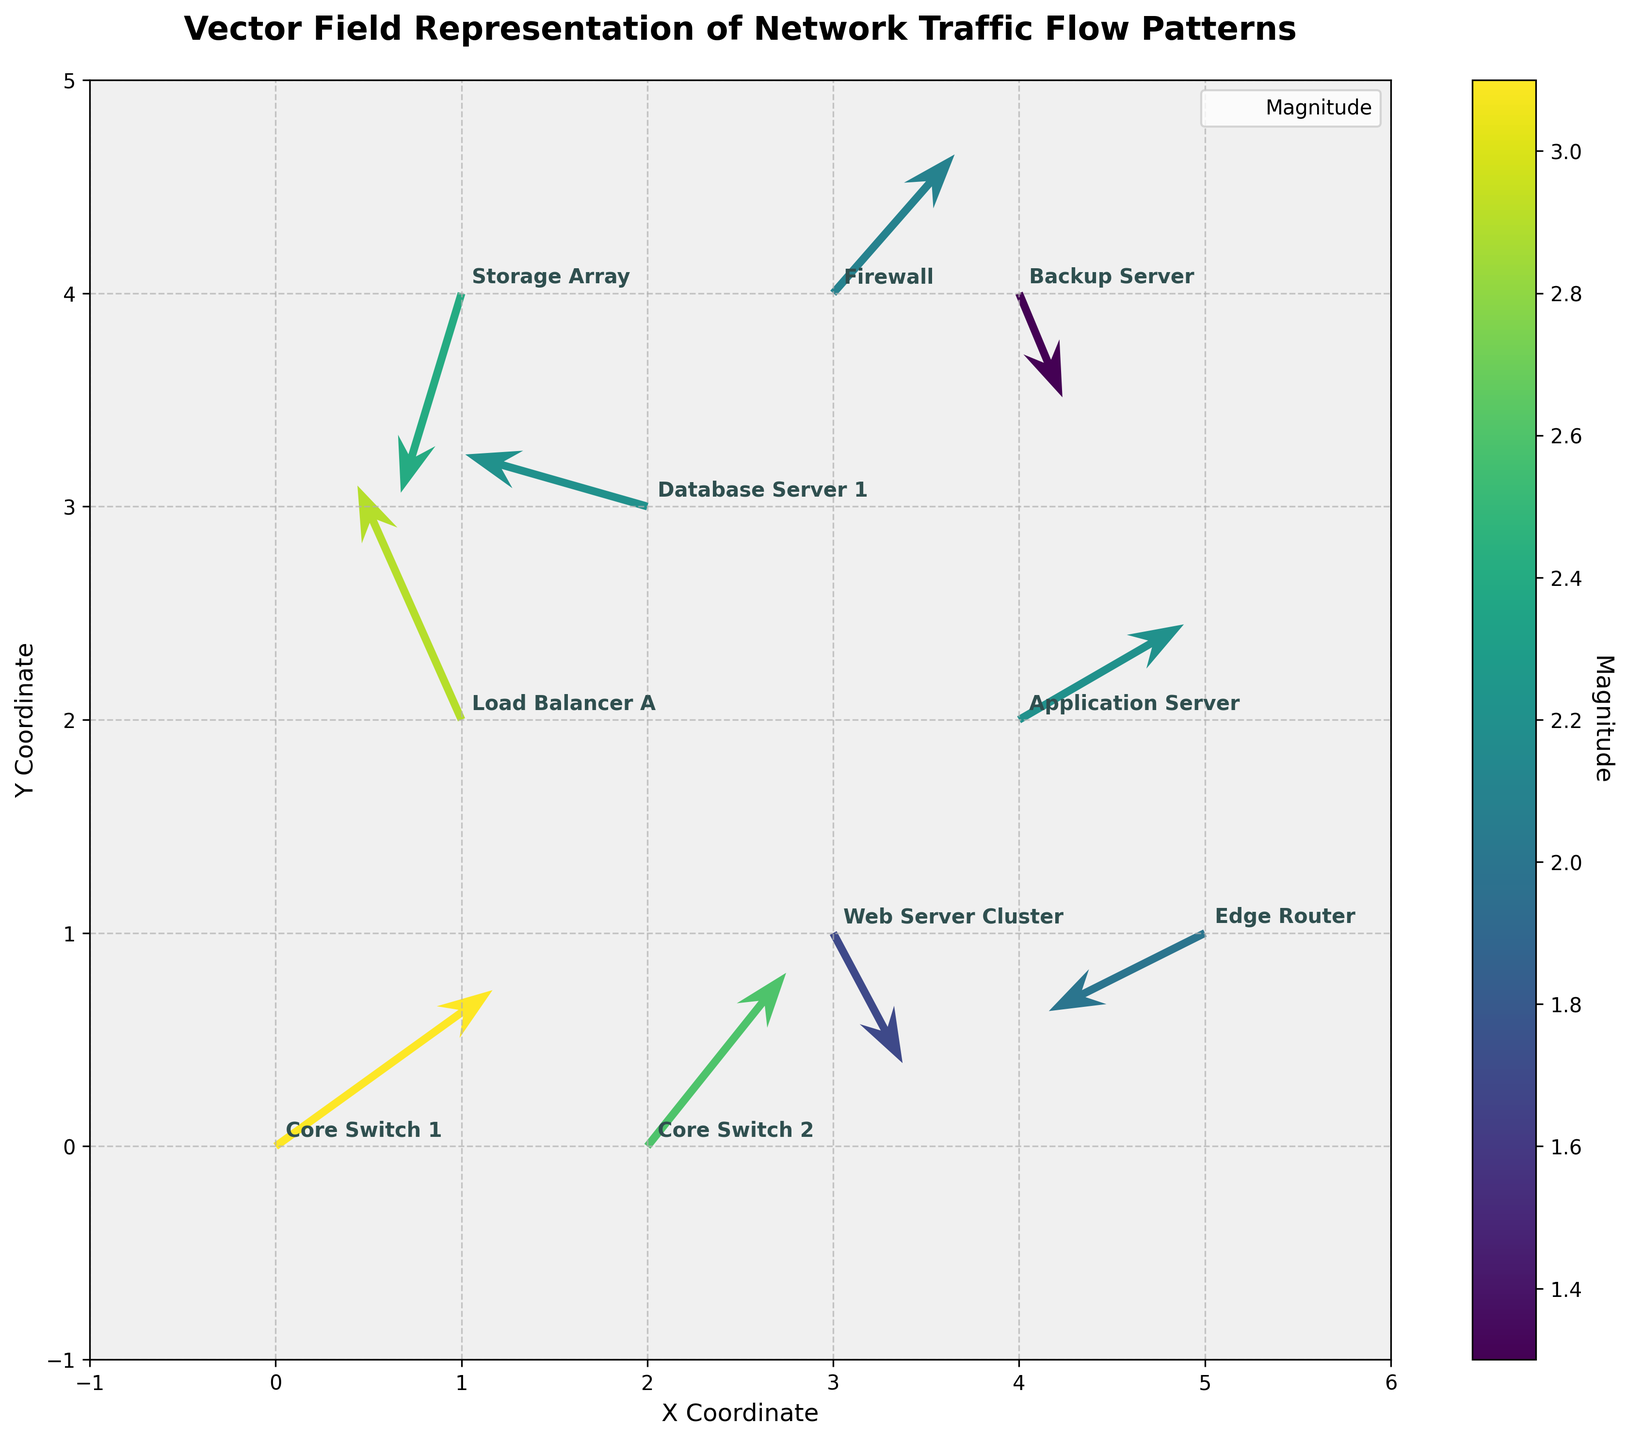Which data point has the highest magnitude? The colorbar indicates the magnitude of each vector. By observing the colors, the data point at (0,0) labeled "Core Switch 1" has the highest intensity, meaning it has the highest magnitude.
Answer: Core Switch 1 What is the title of the plot? The title is typically positioned at the top of the plot. In this plot, the title reads "Vector Field Representation of Network Traffic Flow Patterns".
Answer: Vector Field Representation of Network Traffic Flow Patterns What is the direction of the vector at (4, 2)? The vector at (4, 2) is labeled "Application Server". Observing its arrow, it points upward and to the right. Thus, its direction is northeast.
Answer: Northeast Which data point has a vector pointing southeast? By examining the plot, the vector at (1, 4) labeled "Storage Array" points downward and to the right, which corresponds to a southeast direction.
Answer: Storage Array Compare the magnitudes of the vectors at (1, 2) and (4, 4). Which one is larger? The color of the vector at (1, 2) is more intense than that of the vector at (4, 4), indicating a higher magnitude.
Answer: The vector at (1, 2) Add the U components of the vectors at (3, 1) and (2, 3). What is the result? The U component at (3, 1) is 0.8 and at (2, 3) is -2.1. Adding these, 0.8 + (-2.1) = -1.3
Answer: -1.3 What is the color used to represent the lowest magnitude on the colorbar? The colorbar shows a gradient from dark to bright colors. The lowest magnitude is represented by dark blue.
Answer: Dark blue What are the axes labels of this plot? The x-axis and y-axis labels are usually placed next to the axes. In this case, the x-axis is labeled "X Coordinate" and the y-axis is labeled "Y Coordinate".
Answer: X Coordinate, Y Coordinate Which label has a vector with a positive V component at (0,0)? At (0, 0), the label is "Core Switch 1" and its vector has a V component of 1.8, which is positive.
Answer: Core Switch 1 If you scale the magnitude of "Web Server Cluster" vector by 2, what would it be? The magnitude of "Web Server Cluster" is 1.7. Scaling it by 2, we get 1.7 * 2 = 3.4.
Answer: 3.4 